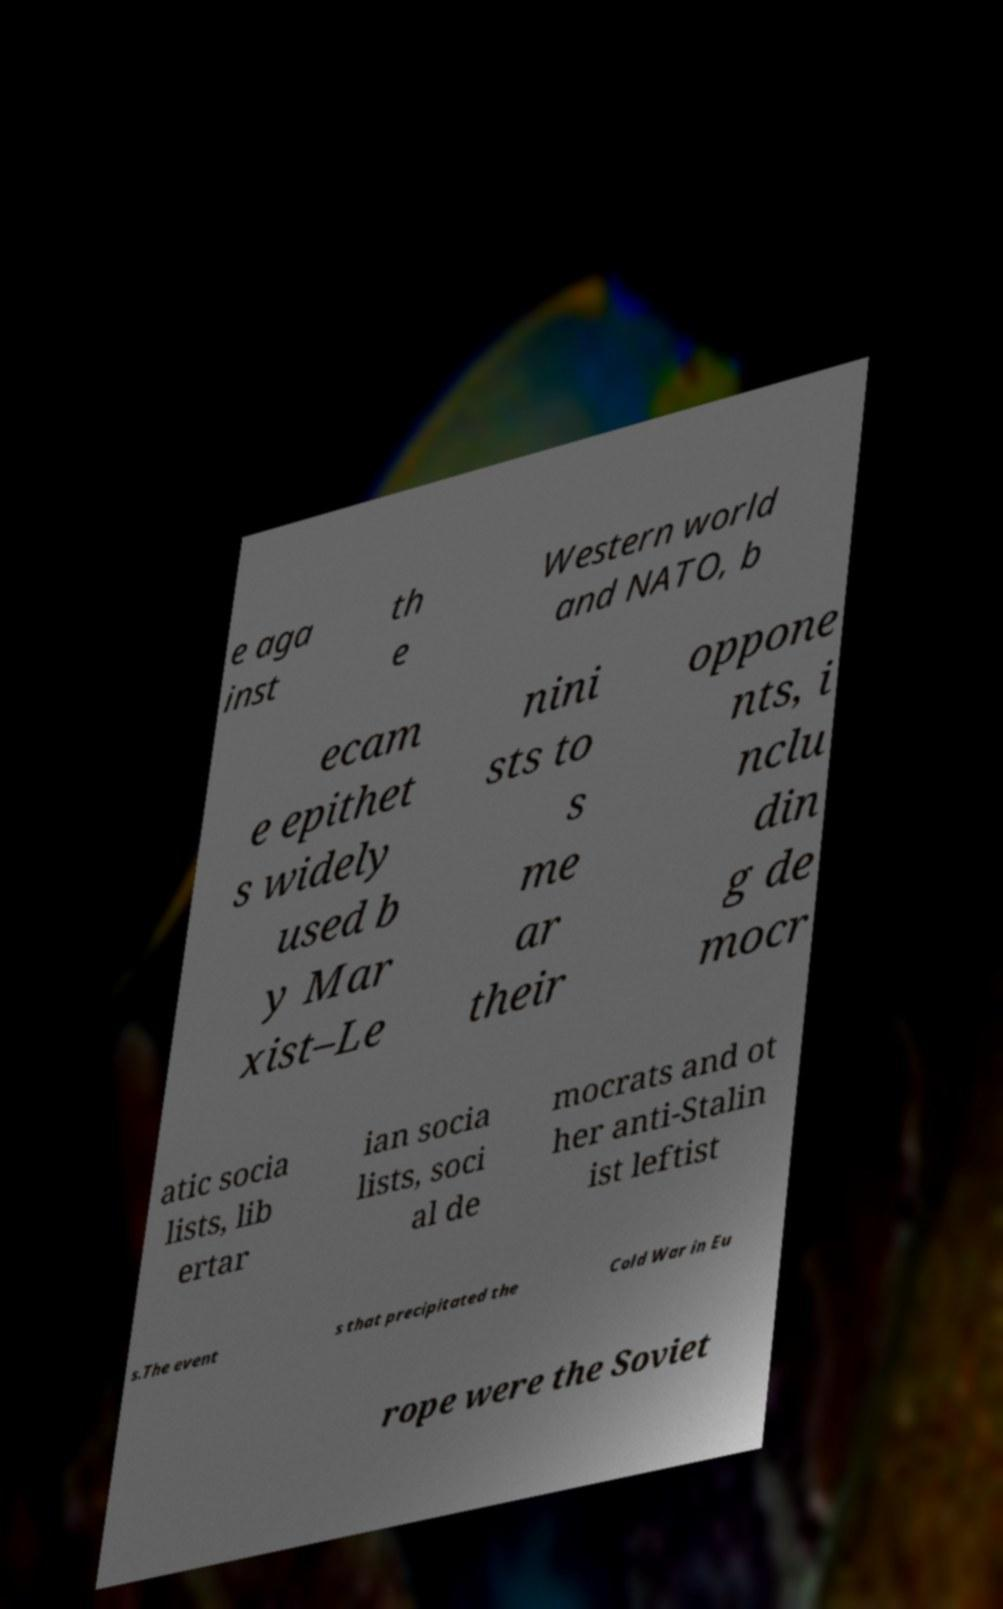I need the written content from this picture converted into text. Can you do that? e aga inst th e Western world and NATO, b ecam e epithet s widely used b y Mar xist–Le nini sts to s me ar their oppone nts, i nclu din g de mocr atic socia lists, lib ertar ian socia lists, soci al de mocrats and ot her anti-Stalin ist leftist s.The event s that precipitated the Cold War in Eu rope were the Soviet 